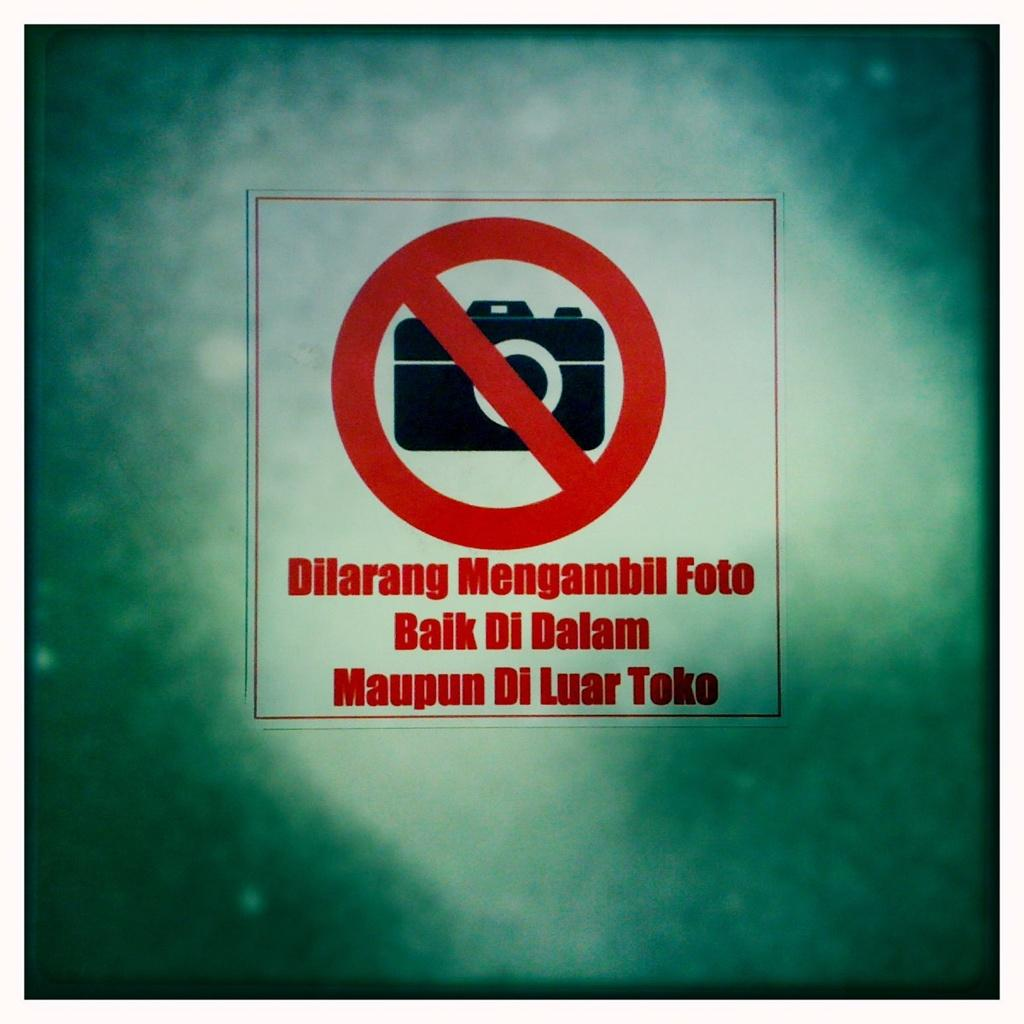What can be found in the image that contains written text? There is a picture of a camera in the image that contains written text. Can you describe the picture in the image? The picture in the image is of a camera. How many dogs are playing in the image? There are no dogs present in the image. What type of pleasure can be seen in the image? There is no indication of pleasure in the image; it contains text and a picture of a camera. 